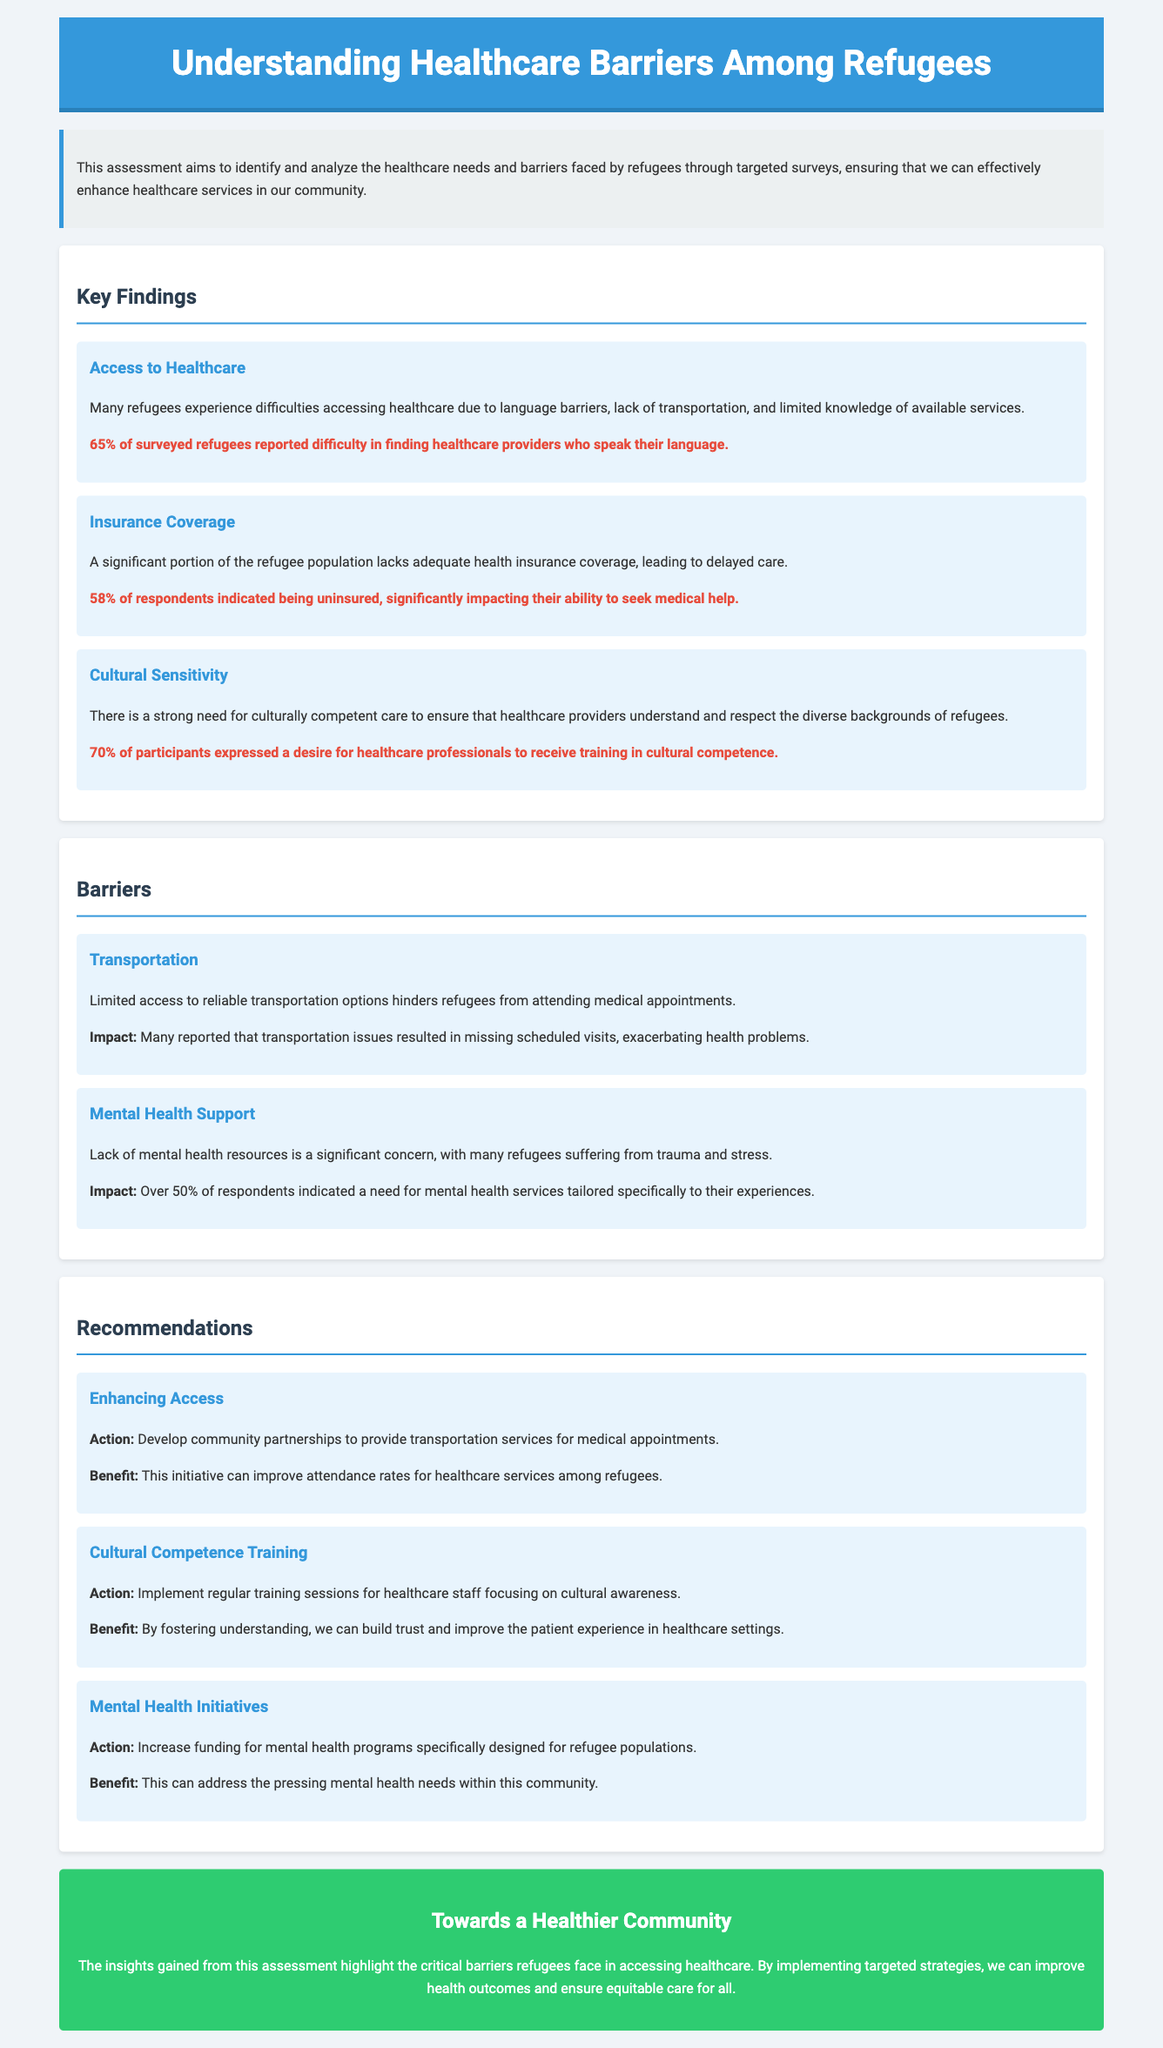what percentage of surveyed refugees reported difficulty finding healthcare providers who speak their language? The document states that 65% of surveyed refugees have reported difficulties in finding healthcare providers who speak their language.
Answer: 65% what is the percentage of respondents indicated being uninsured? The document indicates that 58% of respondents lack adequate health insurance coverage.
Answer: 58% how many participants expressed a desire for healthcare professionals to receive cultural competence training? The document highlights that 70% of participants expressed the need for training in cultural competence.
Answer: 70% what is the primary transportation barrier mentioned in the document? The document notes that limited access to reliable transportation options hinders refugees from attending medical appointments.
Answer: Transportation what is one of the significant mental health concerns for refugees? Over 50% of respondents indicated a need for mental health services tailored specifically to their experiences.
Answer: Trauma what action is proposed to enhance access to healthcare? The document recommends developing community partnerships to provide transportation services for medical appointments.
Answer: Transportation services what benefit is expected from cultural competence training for healthcare staff? The expected benefit is that fostering understanding can build trust and improve the patient experience in healthcare settings.
Answer: Build trust what is the overall goal of the healthcare needs assessment? The overall goal is to identify and analyze the healthcare needs and barriers faced by refugees to enhance healthcare services.
Answer: Enhance healthcare services what color is the section heading for 'Barriers'? The section heading for 'Barriers' is styled in the color #2c3e50 according to the document.
Answer: Dark blue 